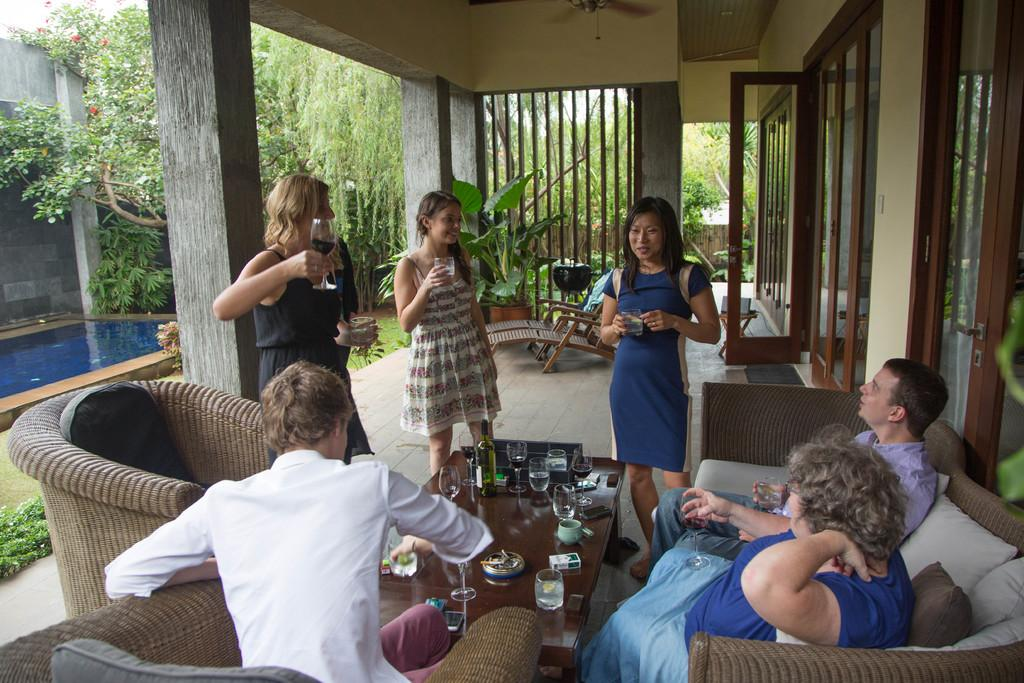How many people are in the image? There is a group of people in the image, but the exact number is not specified. What is behind the group of people? The group of people is in front of a table. What can be seen on the table? There is a cup and glasses on the table. What can be seen in the background of the image? There are trees and a swimming pool in the background of the image. Who is the creator of the swimming pool in the image? There is no information about the creator of the swimming pool in the image. Are there any parents in the group of people? The image does not provide information about the relationships between the people in the group, so it is not possible to determine if any of them are parents. 